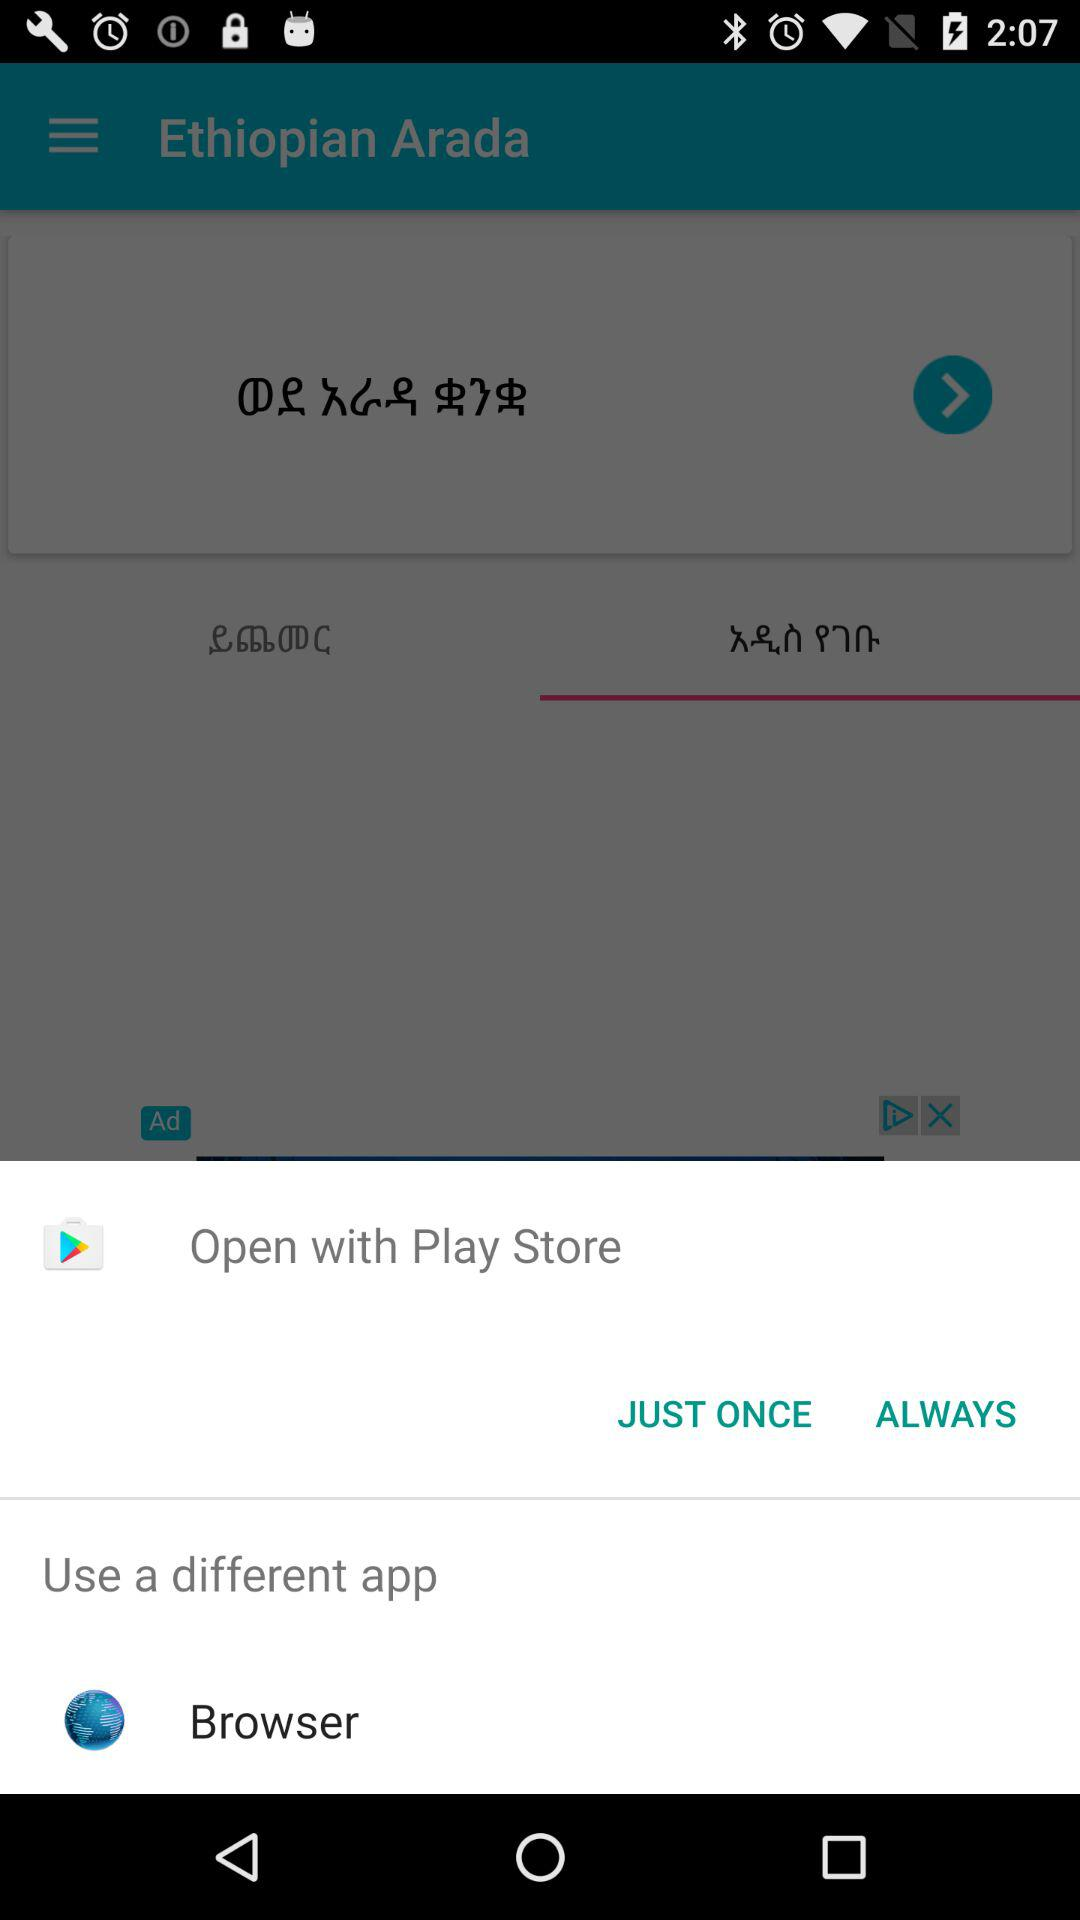Which is the different option to open? The different option is "Browser". 